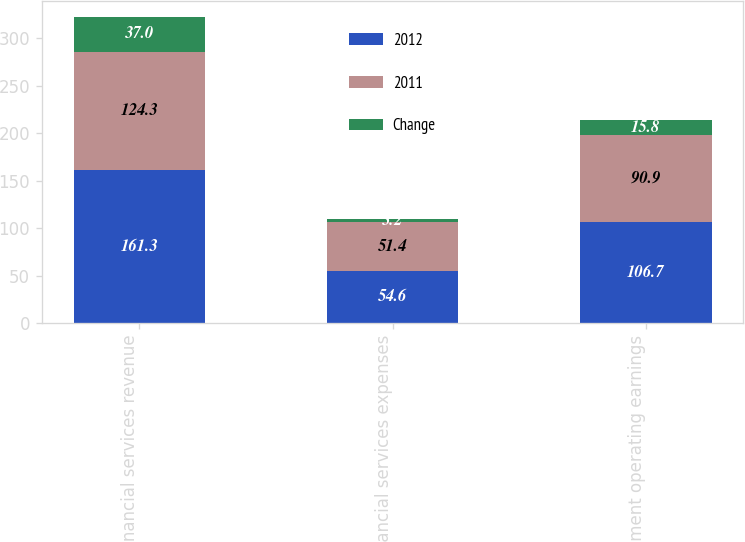Convert chart to OTSL. <chart><loc_0><loc_0><loc_500><loc_500><stacked_bar_chart><ecel><fcel>Financial services revenue<fcel>Financial services expenses<fcel>Segment operating earnings<nl><fcel>2012<fcel>161.3<fcel>54.6<fcel>106.7<nl><fcel>2011<fcel>124.3<fcel>51.4<fcel>90.9<nl><fcel>Change<fcel>37<fcel>3.2<fcel>15.8<nl></chart> 